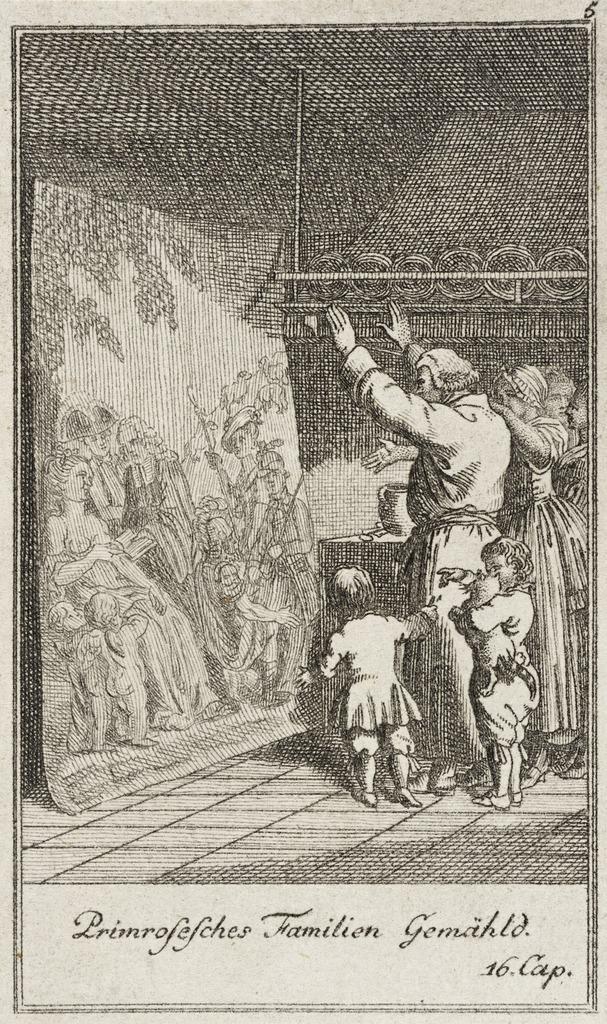In one or two sentences, can you explain what this image depicts? In this picture we can see a paper on which there is a sketch of some persons and two kids standing on the ground. On the left we can see the sketch of group of people sitting. At the bottom there is a text on the image. 